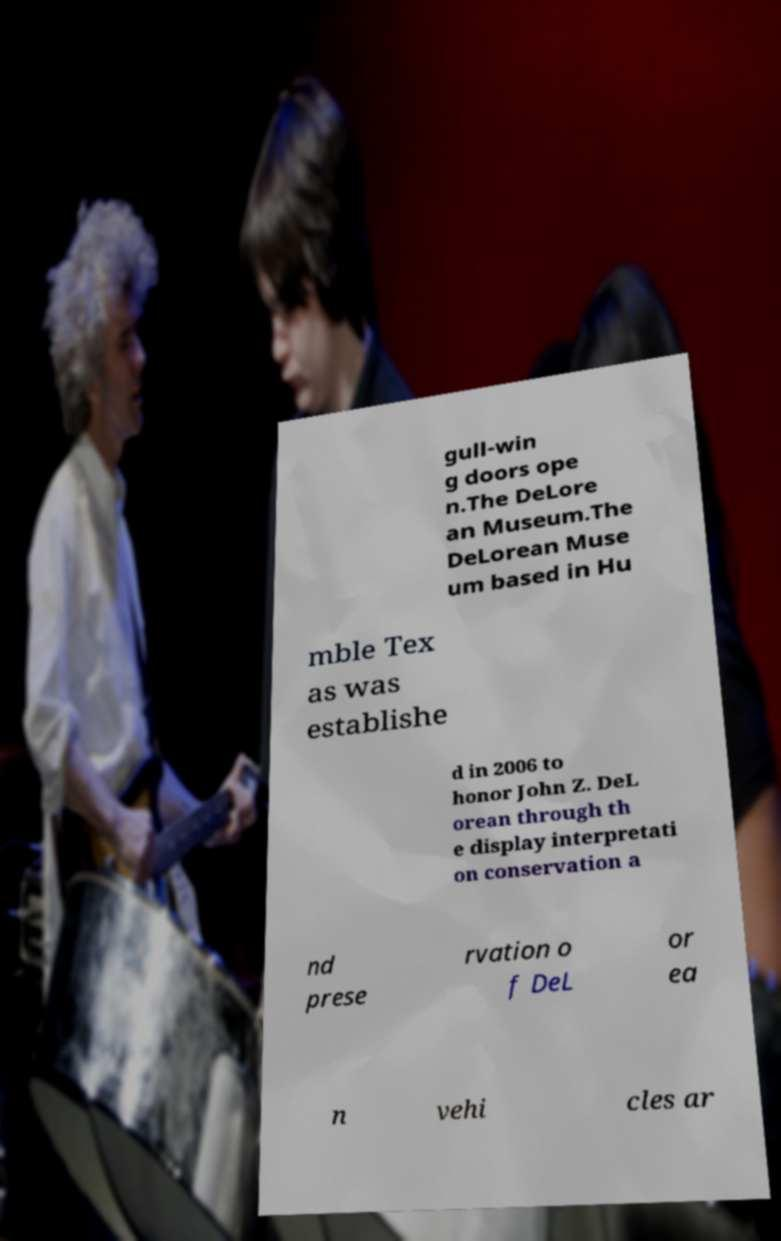What messages or text are displayed in this image? I need them in a readable, typed format. gull-win g doors ope n.The DeLore an Museum.The DeLorean Muse um based in Hu mble Tex as was establishe d in 2006 to honor John Z. DeL orean through th e display interpretati on conservation a nd prese rvation o f DeL or ea n vehi cles ar 